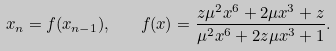Convert formula to latex. <formula><loc_0><loc_0><loc_500><loc_500>x _ { n } = f ( x _ { n - 1 } ) , \quad f ( x ) = \frac { z { \mu } ^ { 2 } x ^ { 6 } + 2 \mu x ^ { 3 } + z } { { \mu } ^ { 2 } x ^ { 6 } + 2 z \mu x ^ { 3 } + 1 } .</formula> 